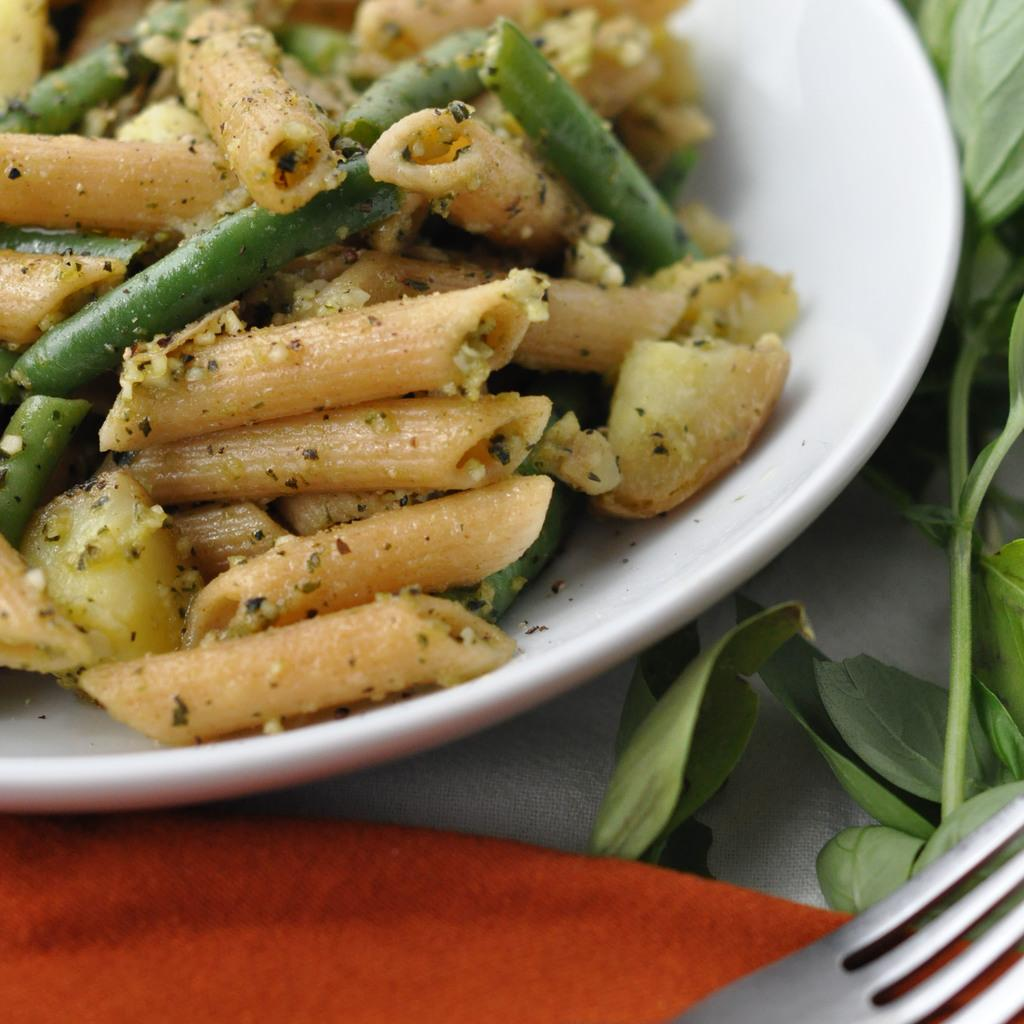What is the color of the platter in the image? The platter in the image is white. What food items are on the platter? The platter contains pasta, beans, and other food items. What is used for cleaning or wiping in the image? There is a napkin in the image for cleaning or wiping. What utensil is present in the image? There is a fork in the image. What type of vegetation is visible in the image? There are green leaves and stems in the image. How do the plants move around in the image? There are no plants present in the image, so they cannot move around. 